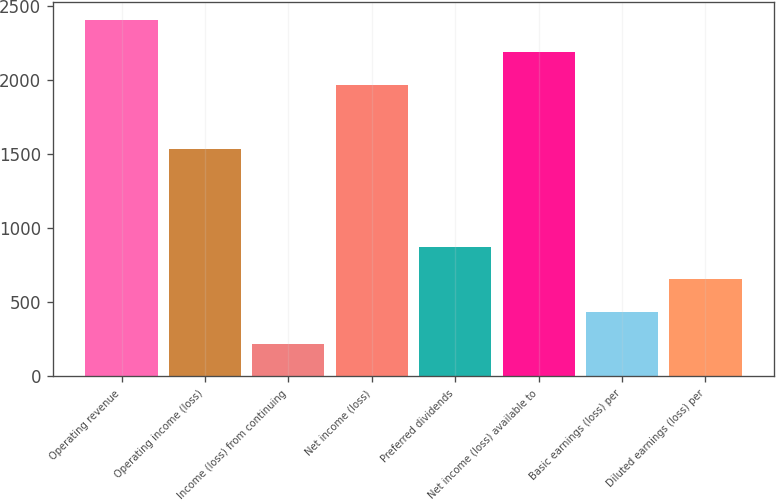<chart> <loc_0><loc_0><loc_500><loc_500><bar_chart><fcel>Operating revenue<fcel>Operating income (loss)<fcel>Income (loss) from continuing<fcel>Net income (loss)<fcel>Preferred dividends<fcel>Net income (loss) available to<fcel>Basic earnings (loss) per<fcel>Diluted earnings (loss) per<nl><fcel>2407.85<fcel>1532.33<fcel>219.05<fcel>1970.09<fcel>875.69<fcel>2188.97<fcel>437.93<fcel>656.81<nl></chart> 